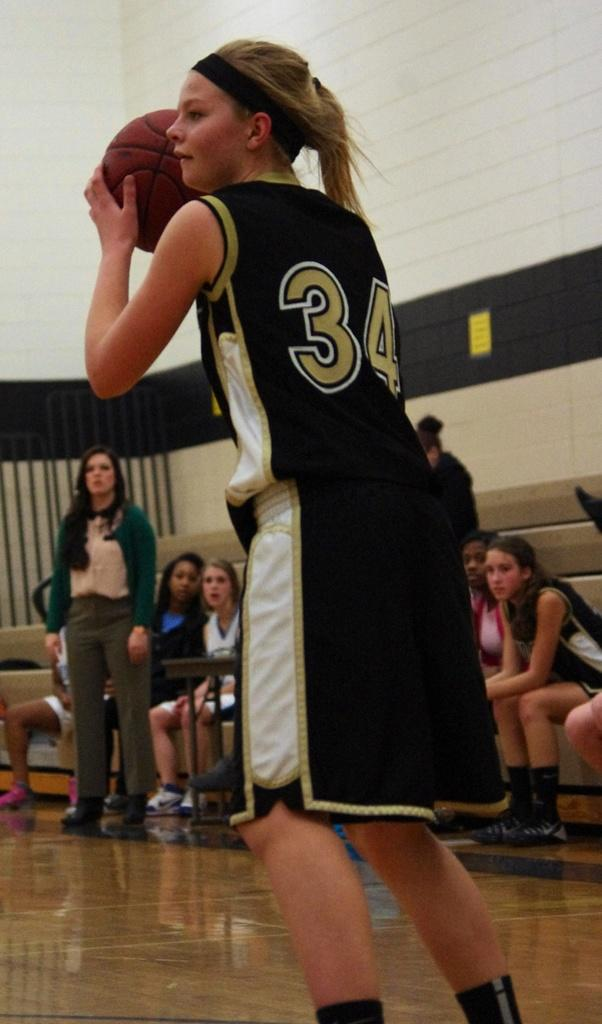<image>
Give a short and clear explanation of the subsequent image. The jersey number the girl is wearing is  number 34 